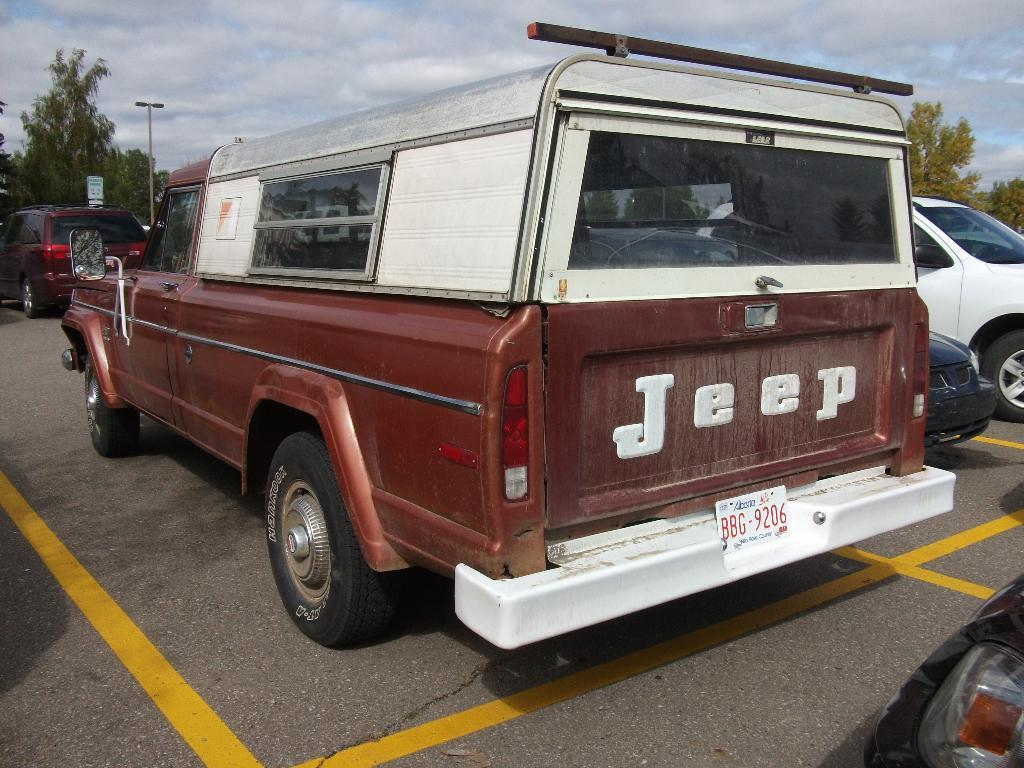What can be seen in the image related to transportation? There are vehicles parked in the image. Where are the vehicles located? The vehicles are in a parking zone. What can be seen in the background of the image? There are trees, a board, and a pole visible in the background. How would you describe the weather based on the image? The sky is cloudy in the background of the image, suggesting a potentially overcast or cloudy day. What day of the week is depicted in the image? The image does not depict a specific day of the week; it only shows parked vehicles and the surrounding environment. 